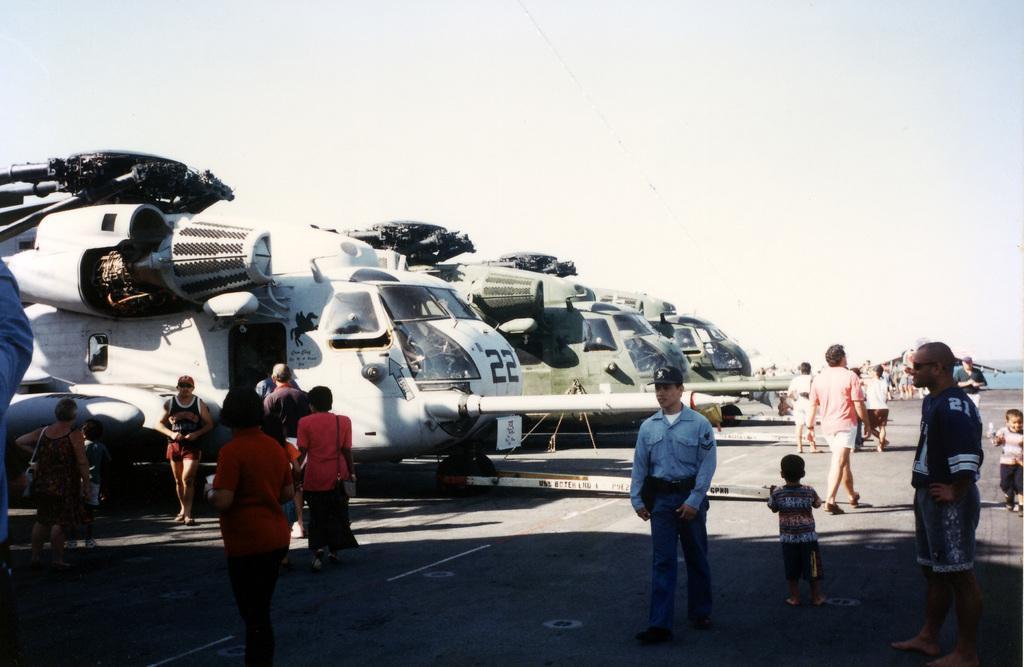How would you summarize this image in a sentence or two? In this picture I can observe airplanes on the runway. There are white and green color airplanes. I can observe some people walking on the runway. In the background there is a sky. 